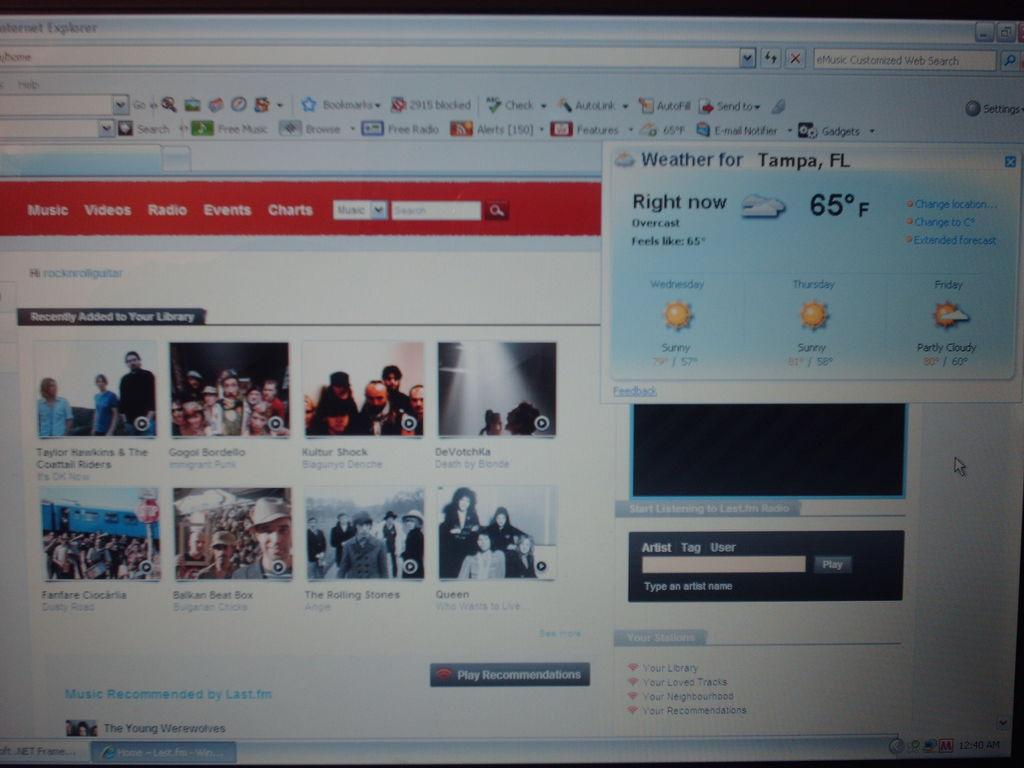What is the main subject of the image? The main subject of the image is a website. What type of content can be found on the website? There are videos and text on the website. What color is the ant crawling on the badge in the image? There is no ant or badge present in the image; it features a website with videos and text. 